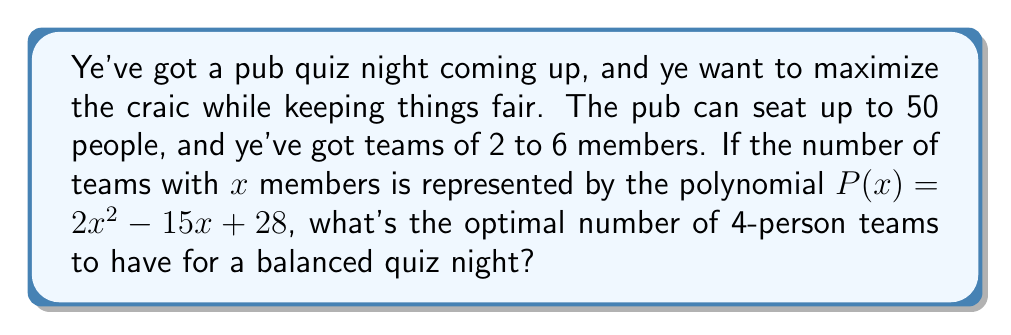Could you help me with this problem? Let's approach this step-by-step, like pouring the perfect pint:

1) First, we need to find the number of teams for each size. We'll use the polynomial $P(x) = 2x^2 - 15x + 28$ where x is the team size:

   For 2-person teams: $P(2) = 2(2)^2 - 15(2) + 28 = 8 - 30 + 28 = 6$ teams
   For 3-person teams: $P(3) = 2(3)^2 - 15(3) + 28 = 18 - 45 + 28 = 1$ team
   For 4-person teams: $P(4) = 2(4)^2 - 15(4) + 28 = 32 - 60 + 28 = 0$ teams
   For 5-person teams: $P(5) = 2(5)^2 - 15(5) + 28 = 50 - 75 + 28 = 3$ teams
   For 6-person teams: $P(6) = 2(6)^2 - 15(6) + 28 = 72 - 90 + 28 = 10$ teams

2) Now, let's calculate the total number of people:
   $(2 * 6) + (3 * 1) + (5 * 3) + (6 * 10) = 12 + 3 + 15 + 60 = 90$ people

3) This exceeds our 50-person limit, so we need to optimize. Let's start by keeping all smaller teams and adjusting the 6-person teams:

   $(2 * 6) + (3 * 1) + (5 * 3) + (6 * 4) = 12 + 3 + 15 + 24 = 54$ people

4) We're close, but still over. Let's add some 4-person teams to balance it out:

   $(2 * 6) + (3 * 1) + (4 * 3) + (5 * 3) = 12 + 3 + 12 + 15 = 42$ people

5) This gives us a good balance and stays under 50. We've added 3 four-person teams.
Answer: 3 four-person teams 